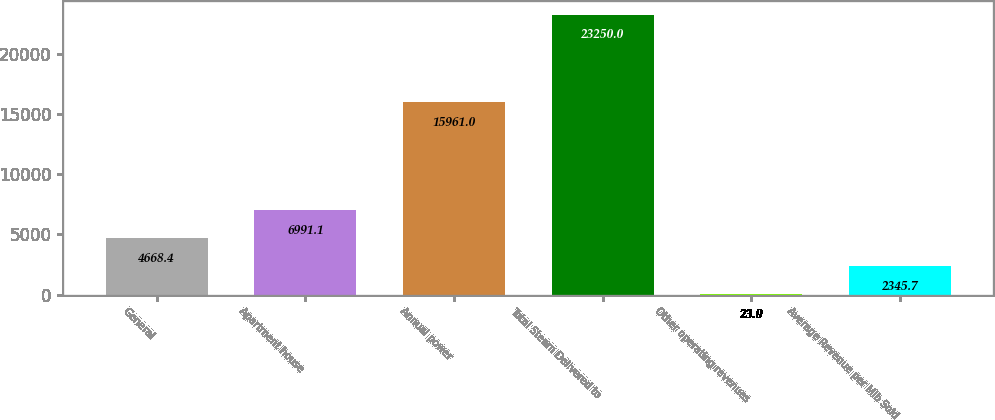Convert chart to OTSL. <chart><loc_0><loc_0><loc_500><loc_500><bar_chart><fcel>General<fcel>Apartment house<fcel>Annual power<fcel>Total Steam Delivered to<fcel>Other operating revenues<fcel>Average Revenue per Mlb Sold<nl><fcel>4668.4<fcel>6991.1<fcel>15961<fcel>23250<fcel>23<fcel>2345.7<nl></chart> 